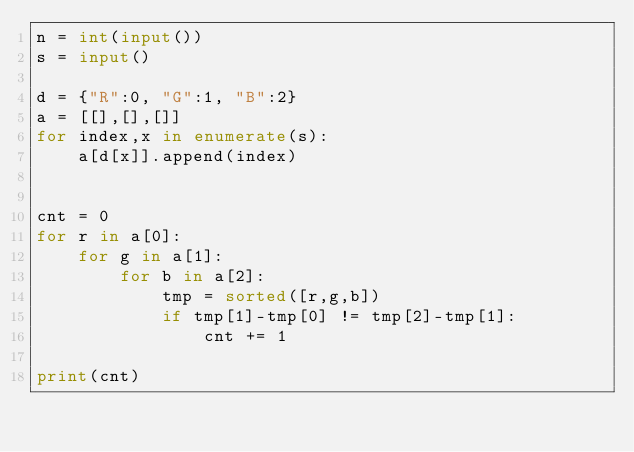Convert code to text. <code><loc_0><loc_0><loc_500><loc_500><_Python_>n = int(input())     
s = input()

d = {"R":0, "G":1, "B":2}
a = [[],[],[]]
for index,x in enumerate(s):
    a[d[x]].append(index)


cnt = 0
for r in a[0]:
    for g in a[1]:
        for b in a[2]:
            tmp = sorted([r,g,b])
            if tmp[1]-tmp[0] != tmp[2]-tmp[1]:
                cnt += 1

print(cnt)


</code> 